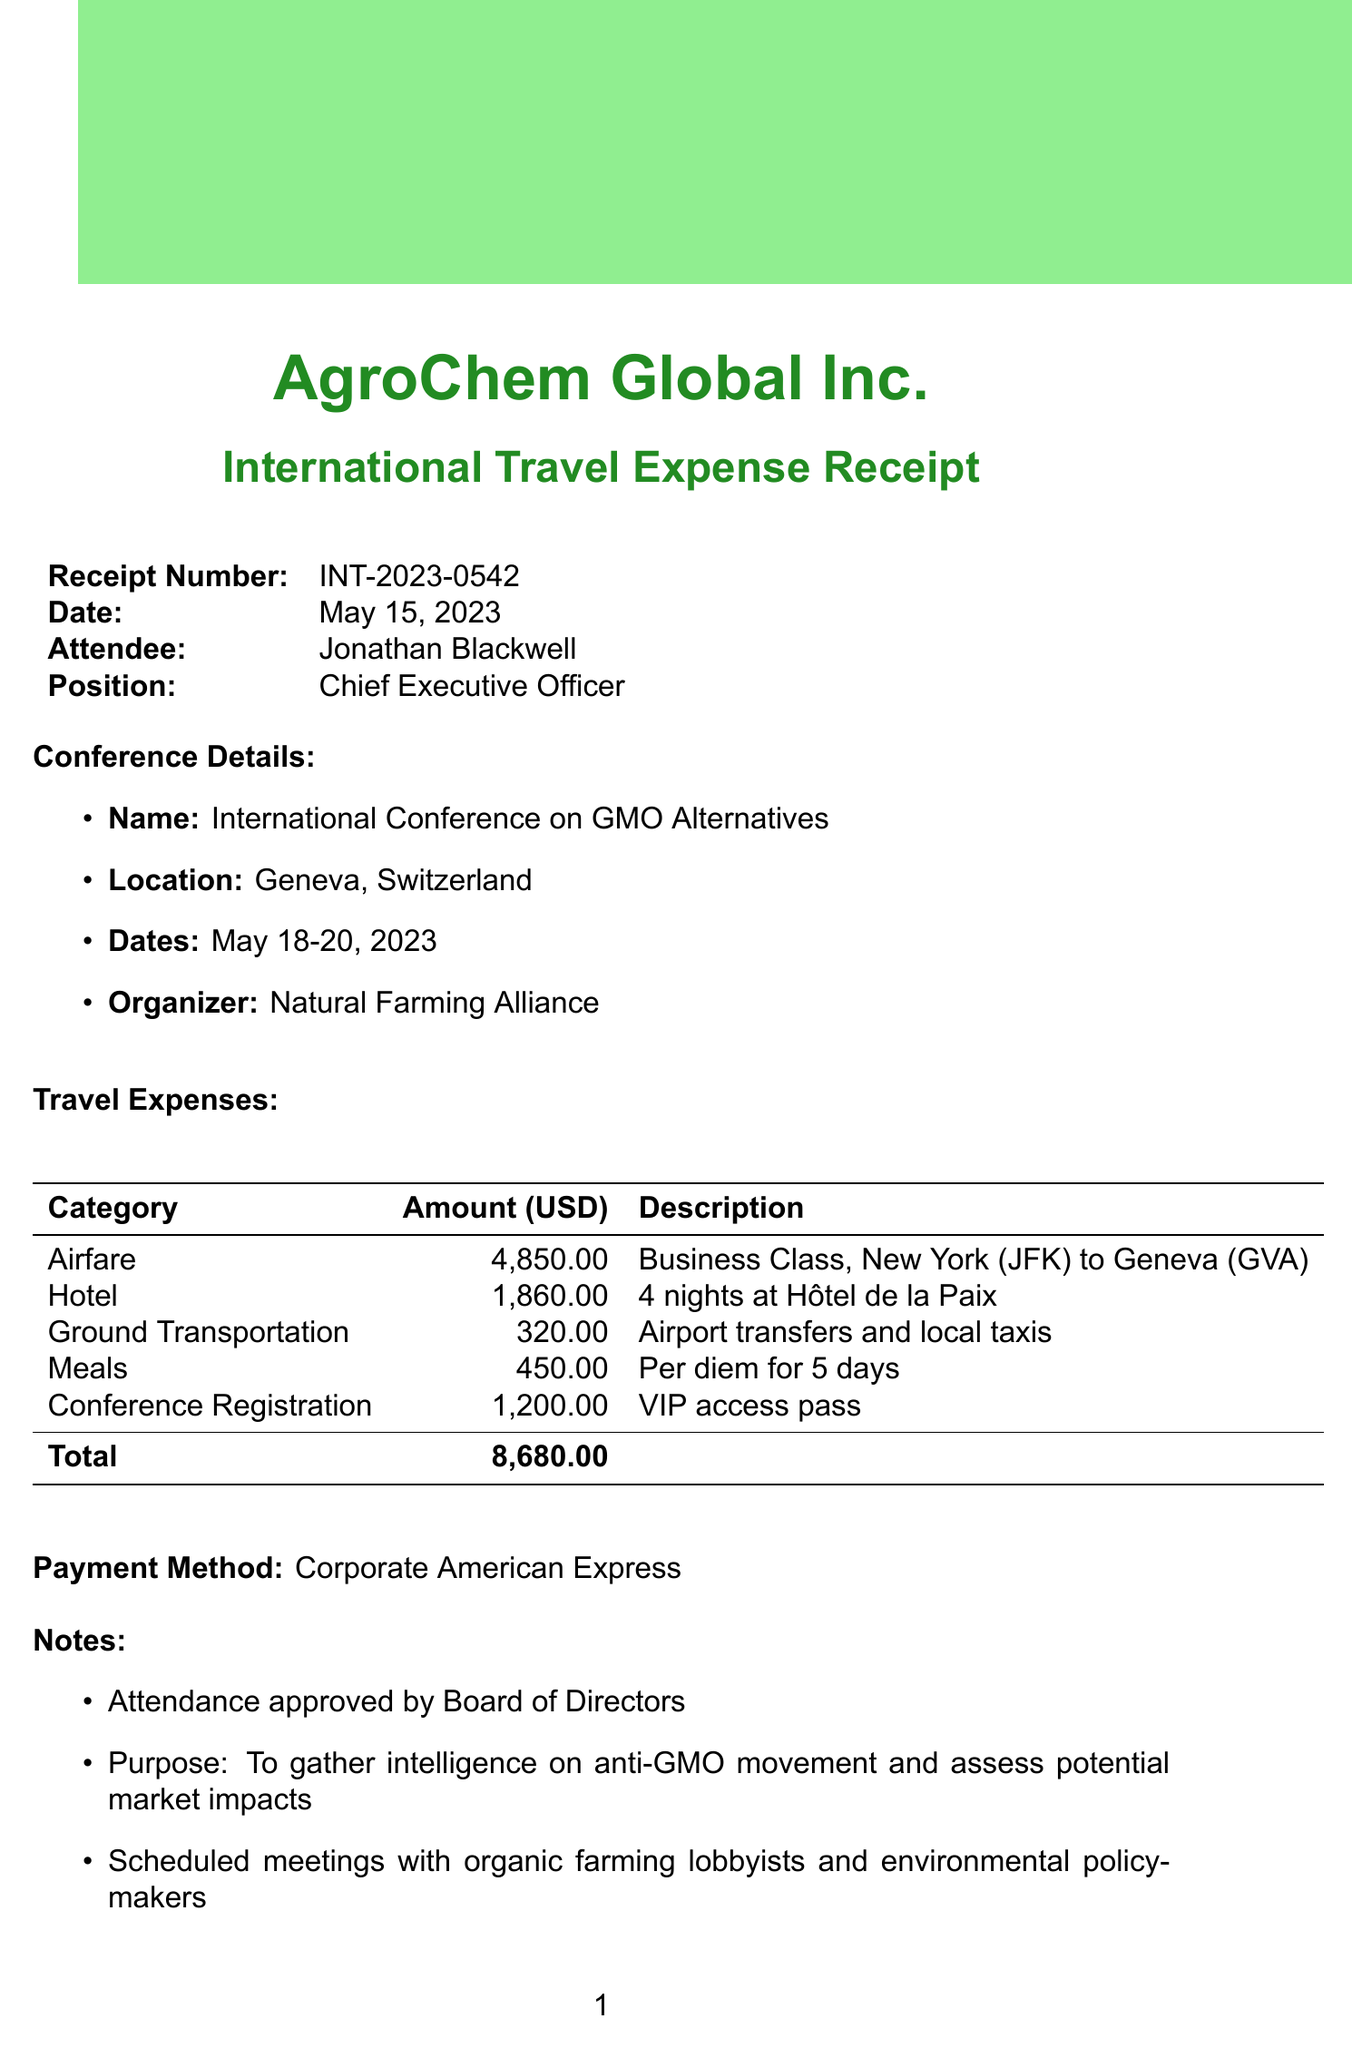What is the receipt number? The receipt number can be found at the top of the document.
Answer: INT-2023-0542 What is the total amount of travel expenses? The total amount is presented at the end of the travel expenses section.
Answer: 8680.00 Who is the attendee of the conference? The attendee's name is listed in the receipt section.
Answer: Jonathan Blackwell What is the location of the conference? The location is mentioned in the conference details section of the document.
Answer: Geneva, Switzerland What is the purpose of the attendance mentioned in the notes? The purpose is stated in the notes section of the document.
Answer: To gather intelligence on anti-GMO movement and assess potential market impacts How many nights did the attendee stay at the hotel? The number of nights is specified in the hotel expense description.
Answer: 4 nights What is the payment method for the expenses? The payment method is outlined near the end of the document.
Answer: Corporate American Express Who submitted the expense receipt? The name of the submitter is included in the final section of the document.
Answer: Emily Chen What is the approval status of the expense receipt? The approval status is indicated at the bottom of the document.
Answer: Pending review by CFO 